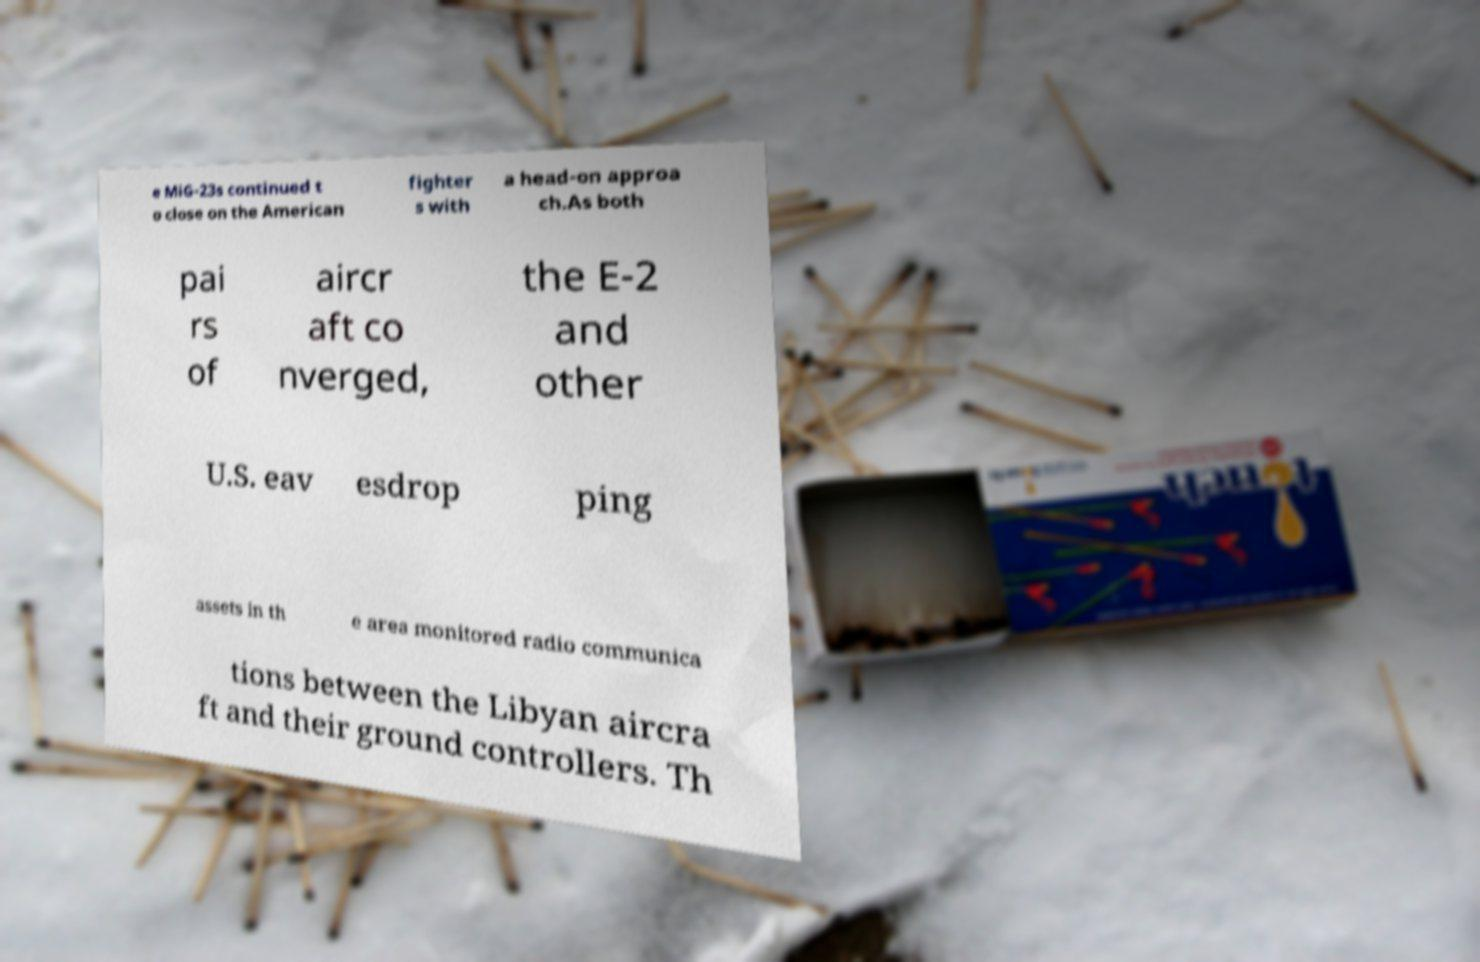What messages or text are displayed in this image? I need them in a readable, typed format. e MiG-23s continued t o close on the American fighter s with a head-on approa ch.As both pai rs of aircr aft co nverged, the E-2 and other U.S. eav esdrop ping assets in th e area monitored radio communica tions between the Libyan aircra ft and their ground controllers. Th 